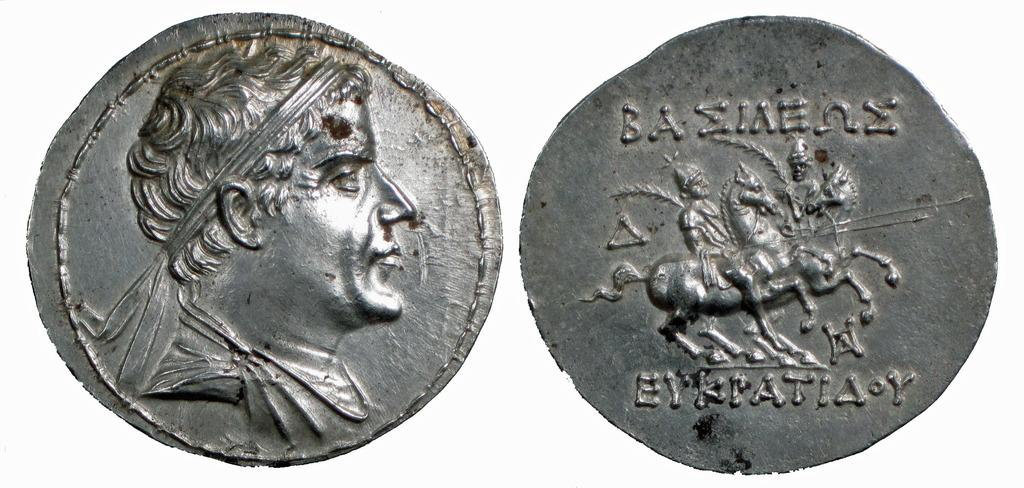Provide a one-sentence caption for the provided image. The front and back of an old coin on which EYKPATIA is written. 